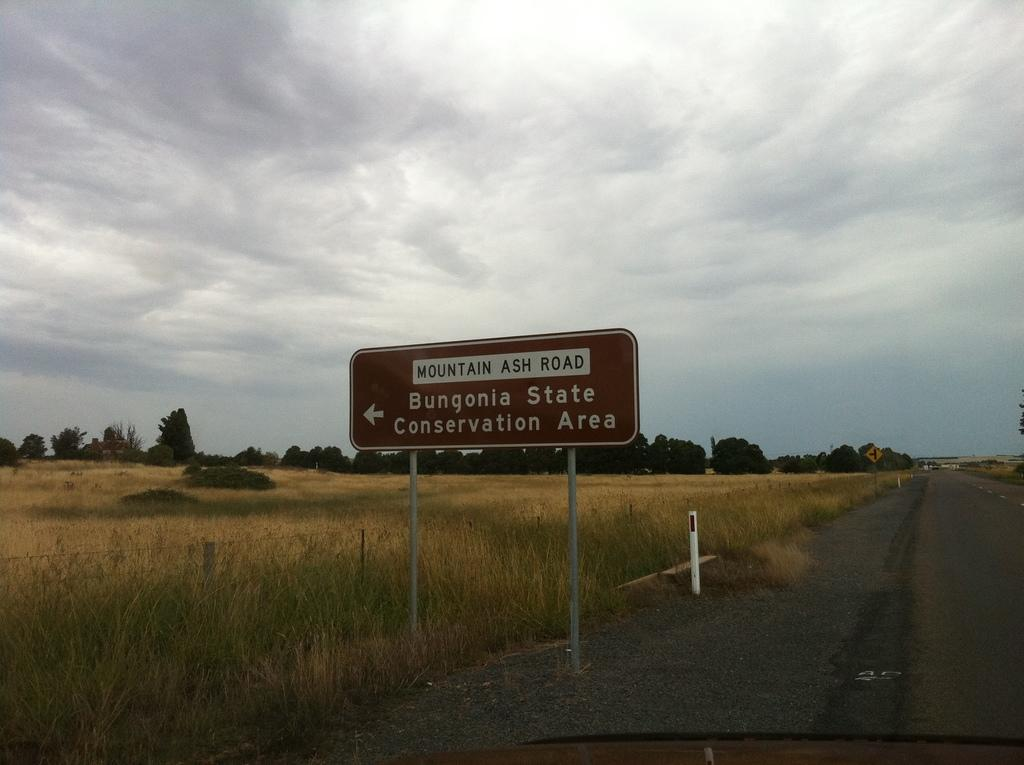<image>
Summarize the visual content of the image. a road sign in a rural setting for Mountain Ash Road 